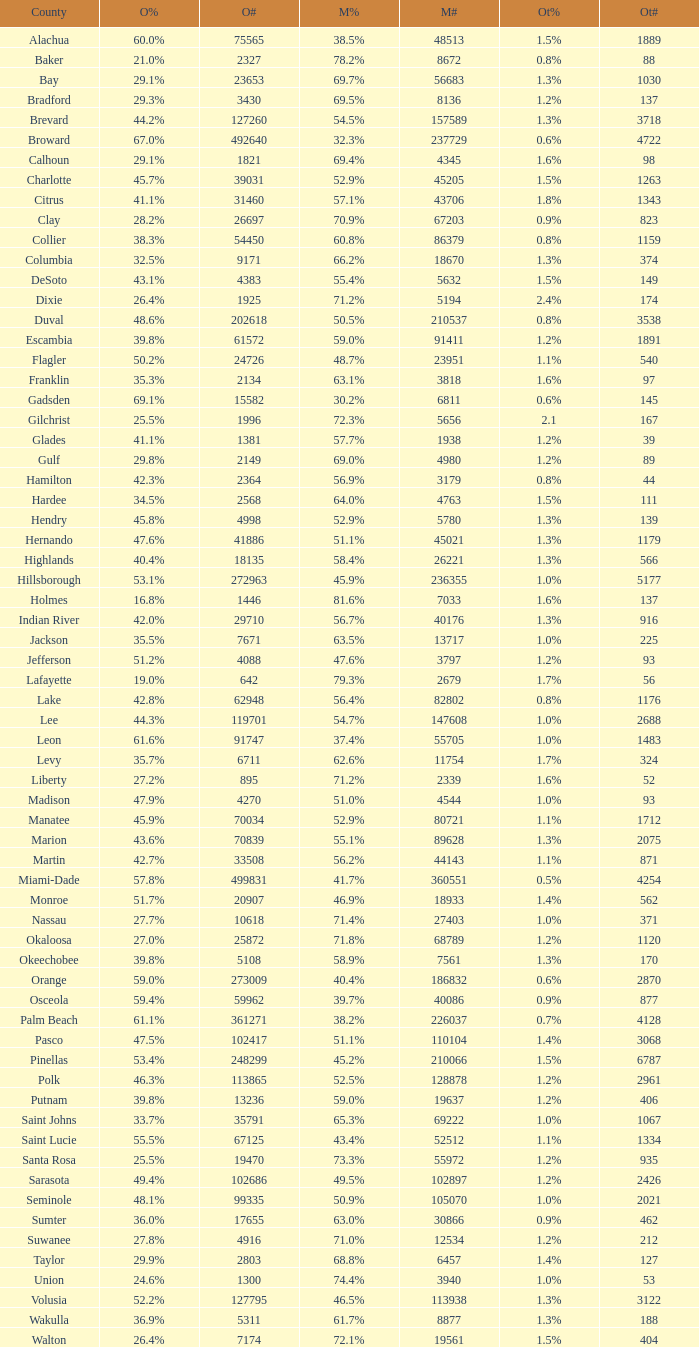How many numbers were recorded under Obama when he had 29.9% voters? 1.0. 